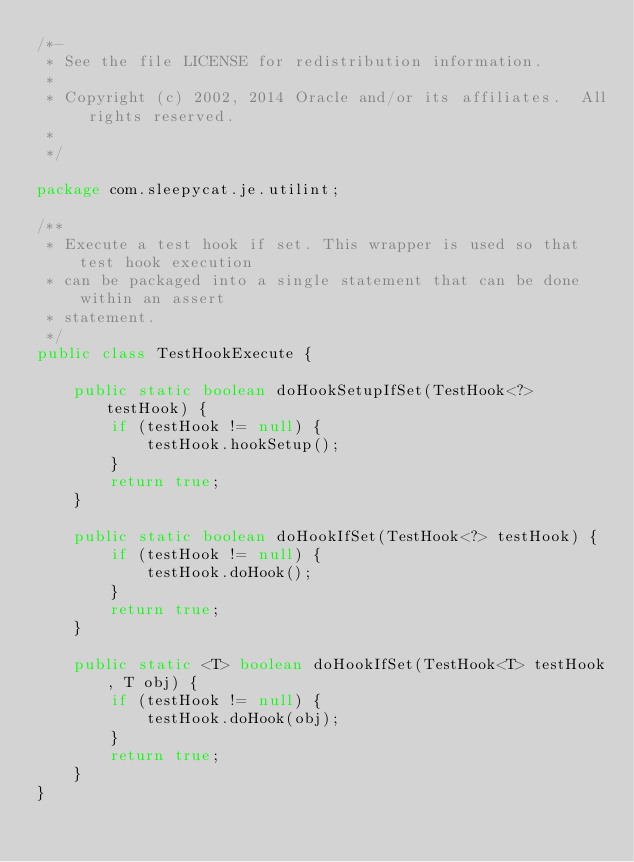<code> <loc_0><loc_0><loc_500><loc_500><_Java_>/*-
 * See the file LICENSE for redistribution information.
 *
 * Copyright (c) 2002, 2014 Oracle and/or its affiliates.  All rights reserved.
 *
 */

package com.sleepycat.je.utilint;

/**
 * Execute a test hook if set. This wrapper is used so that test hook execution
 * can be packaged into a single statement that can be done within an assert
 * statement.
 */
public class TestHookExecute {

    public static boolean doHookSetupIfSet(TestHook<?> testHook) {
        if (testHook != null) {
            testHook.hookSetup();
        }
        return true;
    }

    public static boolean doHookIfSet(TestHook<?> testHook) {
        if (testHook != null) {
            testHook.doHook();
        }
        return true;
    }

    public static <T> boolean doHookIfSet(TestHook<T> testHook, T obj) {
        if (testHook != null) {
            testHook.doHook(obj);
        }
        return true;
    }
}
</code> 